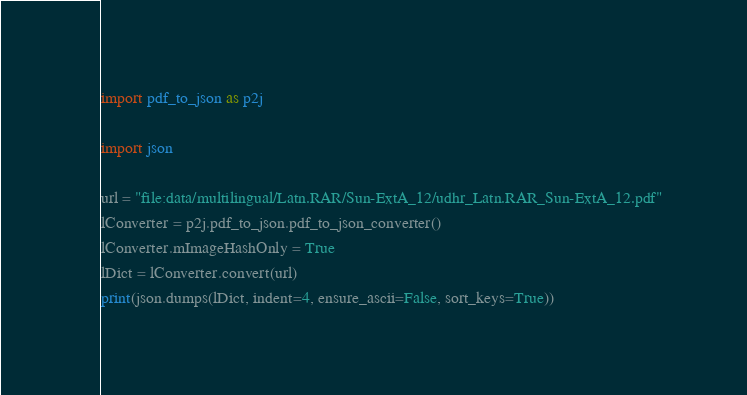Convert code to text. <code><loc_0><loc_0><loc_500><loc_500><_Python_>import pdf_to_json as p2j

import json

url = "file:data/multilingual/Latn.RAR/Sun-ExtA_12/udhr_Latn.RAR_Sun-ExtA_12.pdf"
lConverter = p2j.pdf_to_json.pdf_to_json_converter()
lConverter.mImageHashOnly = True
lDict = lConverter.convert(url)
print(json.dumps(lDict, indent=4, ensure_ascii=False, sort_keys=True))
</code> 